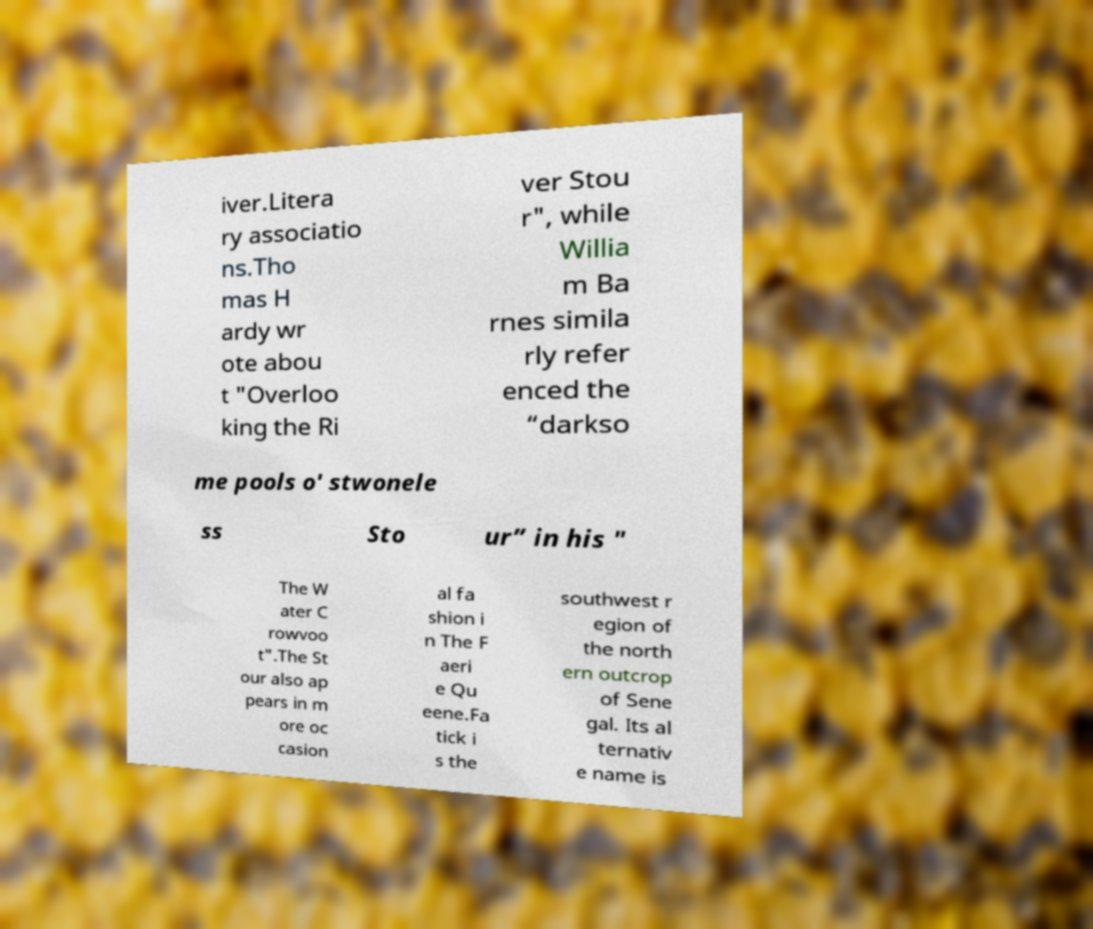Could you extract and type out the text from this image? iver.Litera ry associatio ns.Tho mas H ardy wr ote abou t "Overloo king the Ri ver Stou r", while Willia m Ba rnes simila rly refer enced the “darkso me pools o' stwonele ss Sto ur” in his " The W ater C rowvoo t".The St our also ap pears in m ore oc casion al fa shion i n The F aeri e Qu eene.Fa tick i s the southwest r egion of the north ern outcrop of Sene gal. Its al ternativ e name is 